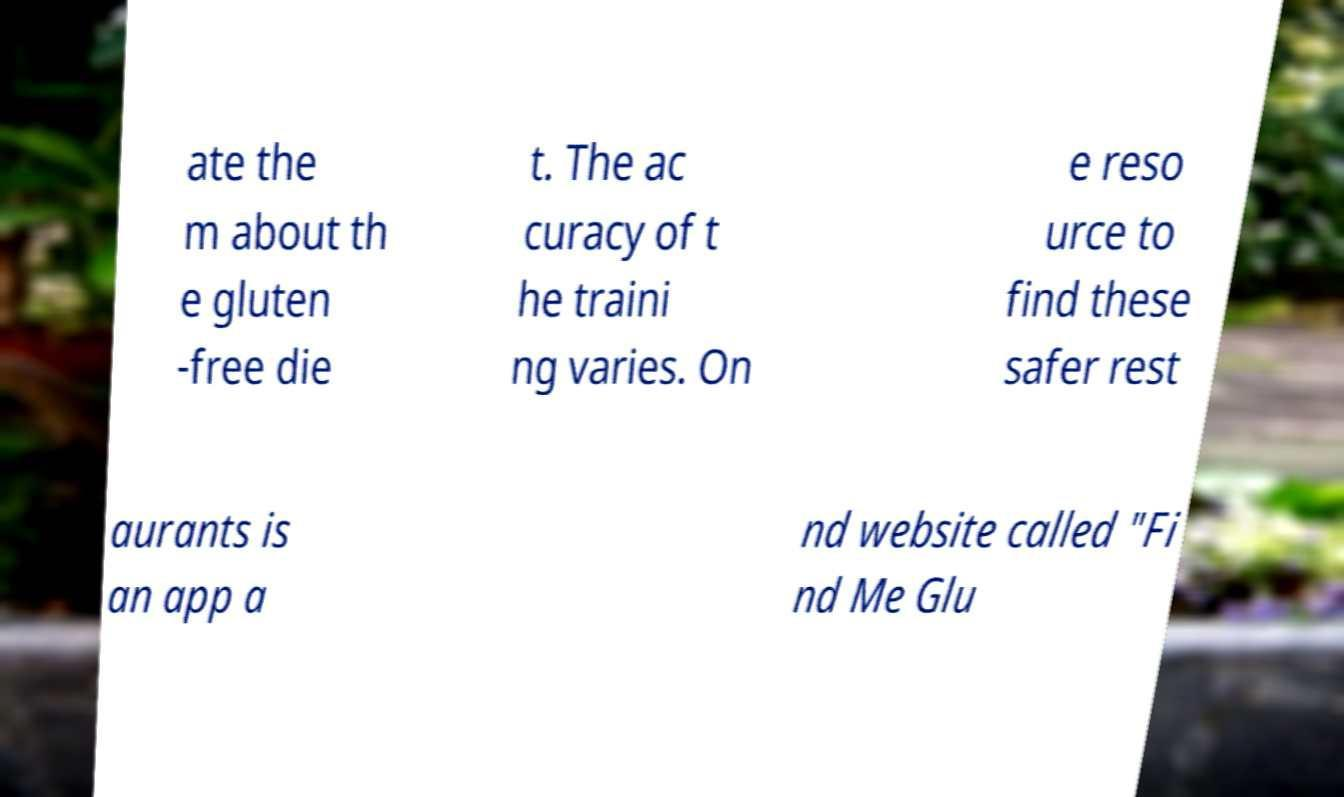For documentation purposes, I need the text within this image transcribed. Could you provide that? ate the m about th e gluten -free die t. The ac curacy of t he traini ng varies. On e reso urce to find these safer rest aurants is an app a nd website called "Fi nd Me Glu 